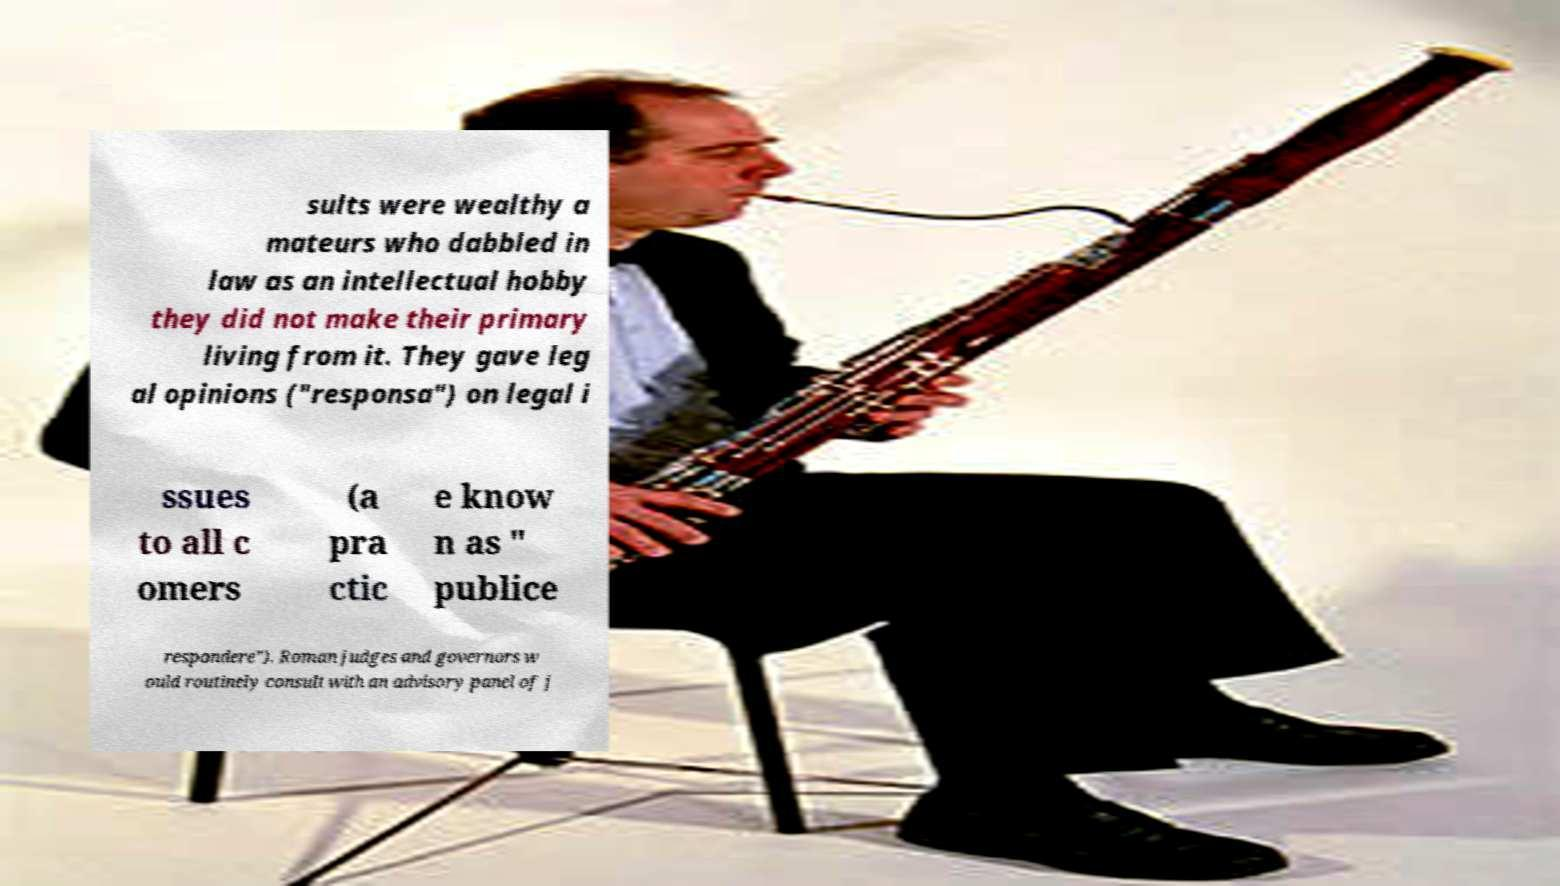For documentation purposes, I need the text within this image transcribed. Could you provide that? sults were wealthy a mateurs who dabbled in law as an intellectual hobby they did not make their primary living from it. They gave leg al opinions ("responsa") on legal i ssues to all c omers (a pra ctic e know n as " publice respondere"). Roman judges and governors w ould routinely consult with an advisory panel of j 